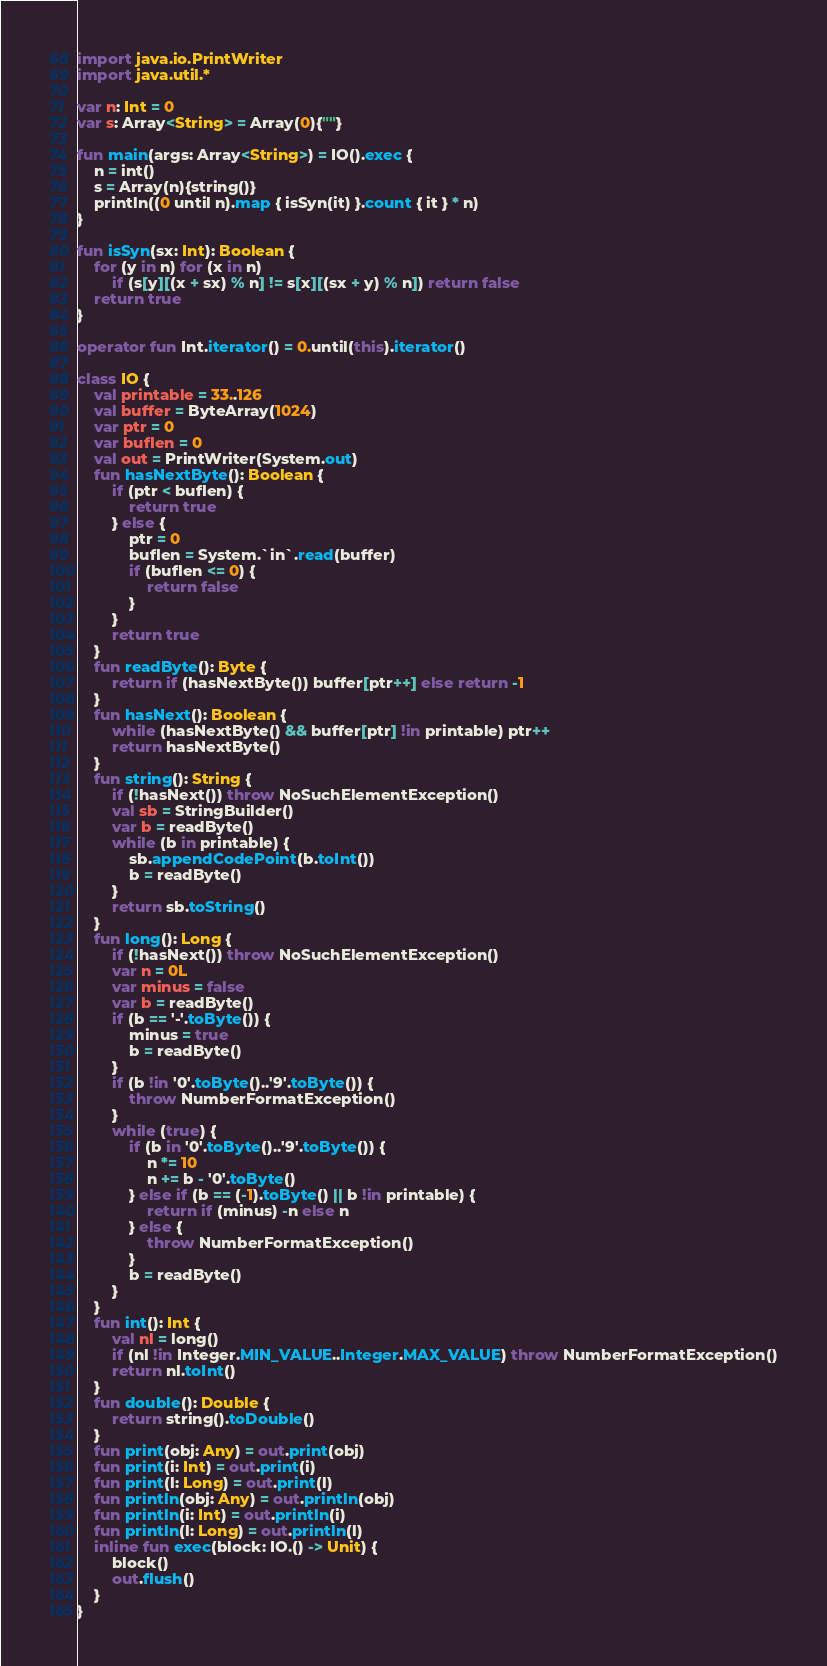Convert code to text. <code><loc_0><loc_0><loc_500><loc_500><_Kotlin_>import java.io.PrintWriter
import java.util.*

var n: Int = 0
var s: Array<String> = Array(0){""}

fun main(args: Array<String>) = IO().exec {
    n = int()
    s = Array(n){string()}
    println((0 until n).map { isSyn(it) }.count { it } * n)
}

fun isSyn(sx: Int): Boolean {
    for (y in n) for (x in n)
        if (s[y][(x + sx) % n] != s[x][(sx + y) % n]) return false
    return true
}

operator fun Int.iterator() = 0.until(this).iterator()

class IO {
    val printable = 33..126
    val buffer = ByteArray(1024)
    var ptr = 0
    var buflen = 0
    val out = PrintWriter(System.out)
    fun hasNextByte(): Boolean {
        if (ptr < buflen) {
            return true
        } else {
            ptr = 0
            buflen = System.`in`.read(buffer)
            if (buflen <= 0) {
                return false
            }
        }
        return true
    }
    fun readByte(): Byte {
        return if (hasNextByte()) buffer[ptr++] else return -1
    }
    fun hasNext(): Boolean {
        while (hasNextByte() && buffer[ptr] !in printable) ptr++
        return hasNextByte()
    }
    fun string(): String {
        if (!hasNext()) throw NoSuchElementException()
        val sb = StringBuilder()
        var b = readByte()
        while (b in printable) {
            sb.appendCodePoint(b.toInt())
            b = readByte()
        }
        return sb.toString()
    }
    fun long(): Long {
        if (!hasNext()) throw NoSuchElementException()
        var n = 0L
        var minus = false
        var b = readByte()
        if (b == '-'.toByte()) {
            minus = true
            b = readByte()
        }
        if (b !in '0'.toByte()..'9'.toByte()) {
            throw NumberFormatException()
        }
        while (true) {
            if (b in '0'.toByte()..'9'.toByte()) {
                n *= 10
                n += b - '0'.toByte()
            } else if (b == (-1).toByte() || b !in printable) {
                return if (minus) -n else n
            } else {
                throw NumberFormatException()
            }
            b = readByte()
        }
    }
    fun int(): Int {
        val nl = long()
        if (nl !in Integer.MIN_VALUE..Integer.MAX_VALUE) throw NumberFormatException()
        return nl.toInt()
    }
    fun double(): Double {
        return string().toDouble()
    }
    fun print(obj: Any) = out.print(obj)
    fun print(i: Int) = out.print(i)
    fun print(l: Long) = out.print(l)
    fun println(obj: Any) = out.println(obj)
    fun println(i: Int) = out.println(i)
    fun println(l: Long) = out.println(l)
    inline fun exec(block: IO.() -> Unit) {
        block()
        out.flush()
    }
}</code> 